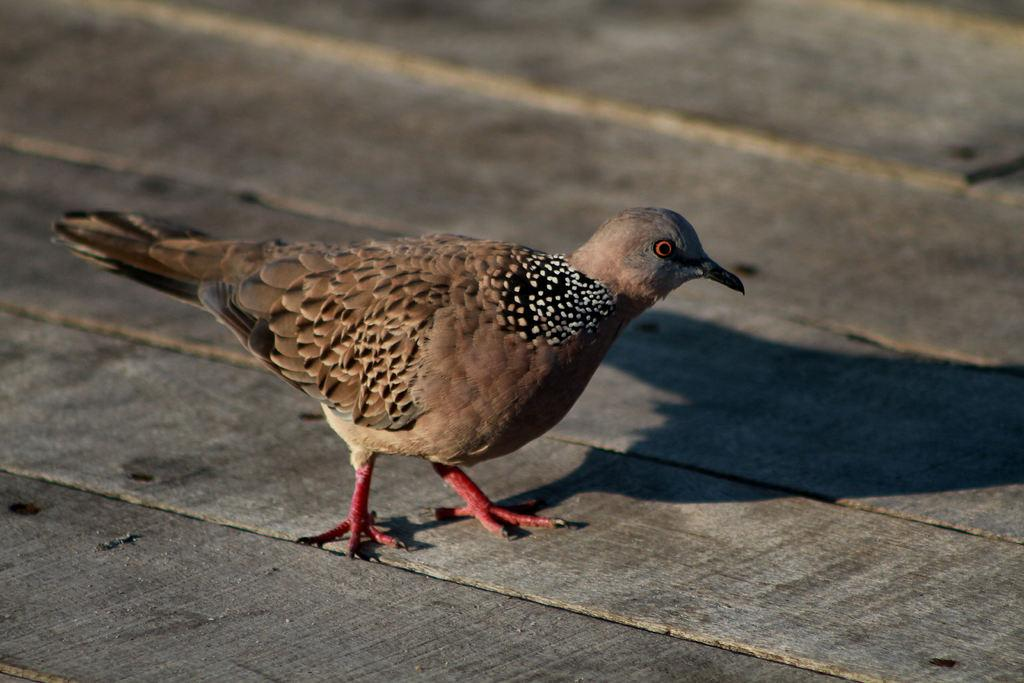What type of animal is present in the image? There is a bird in the image. Where is the bird located? The bird is on a wooden surface. Can you describe the quality of the image? The image is slightly blurred. blurred. Can you see the river in the background of the image? There is no river present in the image. What message is the bird conveying as it says good-bye in the image? The bird is not saying good-bye or conveying any message in the image, as birds do not have the ability to communicate in this manner. 